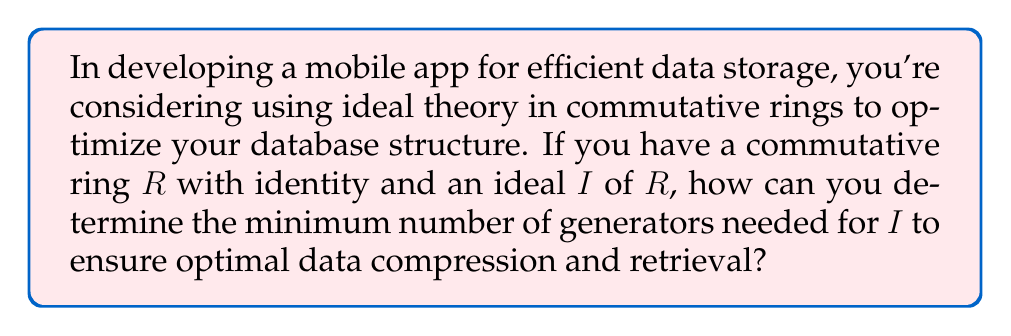Provide a solution to this math problem. To solve this problem, we need to understand the concept of the minimal number of generators for an ideal in a commutative ring, which is closely related to the notion of Krull dimension in algebraic geometry.

1. First, recall that in a commutative ring $R$, an ideal $I$ is said to be finitely generated if there exist elements $a_1, a_2, ..., a_n \in R$ such that $I = (a_1, a_2, ..., a_n)$.

2. The minimal number of generators for an ideal $I$ is the smallest integer $n$ such that $I$ can be generated by $n$ elements. This number is denoted by $\mu(I)$.

3. In the context of data storage and retrieval, $\mu(I)$ can be interpreted as the minimum number of "keys" or "indices" needed to efficiently access and compress the data represented by the ideal $I$.

4. To determine $\mu(I)$, we can use the following theorem:

   For a Noetherian local ring $(R, \mathfrak{m})$ and an ideal $I \subseteq R$, 
   $$\mu(I) = \dim_k(I/\mathfrak{m}I)$$
   where $k = R/\mathfrak{m}$ is the residue field of $R$.

5. This theorem relates the minimal number of generators to the dimension of a certain vector space over the residue field.

6. In practice, to compute $\mu(I)$:
   a. Find a minimal set of generators for $I$ modulo $\mathfrak{m}I$.
   b. Count the number of elements in this set.

7. For a general commutative ring, the process might be more complex, involving localization at maximal ideals and considering the maximum of $\mu(I_\mathfrak{p})$ over all prime ideals $\mathfrak{p}$.

8. In the context of app development, this translates to finding the minimal set of data fields or indices that can generate all other data in your storage structure, thus optimizing both storage efficiency and retrieval speed.
Answer: The minimum number of generators for an ideal $I$ in a Noetherian local ring $(R, \mathfrak{m})$ is given by $\mu(I) = \dim_k(I/\mathfrak{m}I)$, where $k = R/\mathfrak{m}$ is the residue field. This number represents the optimal number of "keys" or "indices" needed for efficient data compression and retrieval in the app's database structure. 